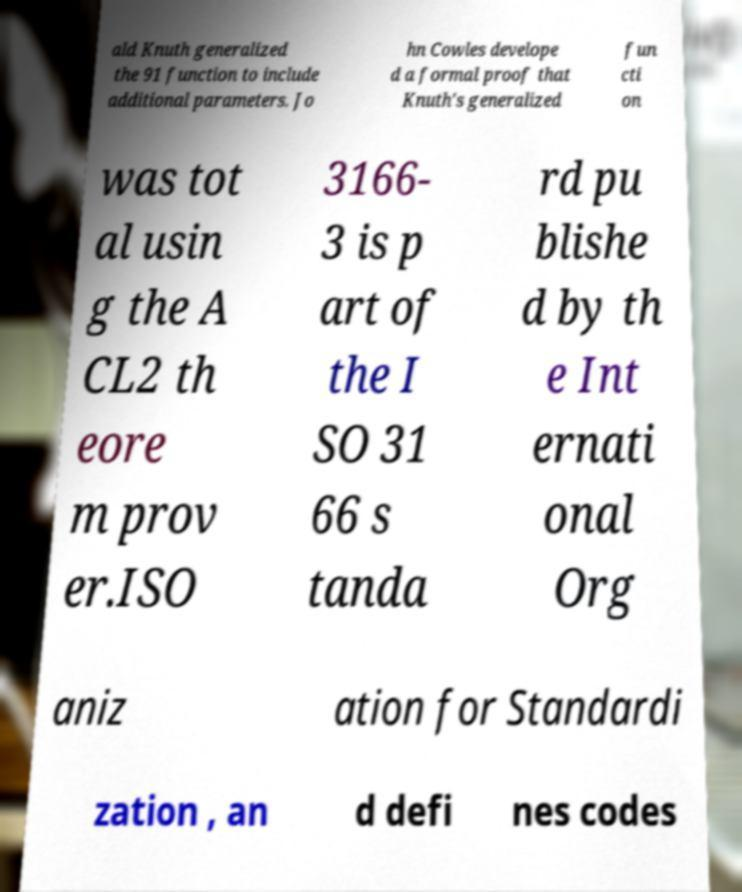Please identify and transcribe the text found in this image. ald Knuth generalized the 91 function to include additional parameters. Jo hn Cowles develope d a formal proof that Knuth's generalized fun cti on was tot al usin g the A CL2 th eore m prov er.ISO 3166- 3 is p art of the I SO 31 66 s tanda rd pu blishe d by th e Int ernati onal Org aniz ation for Standardi zation , an d defi nes codes 